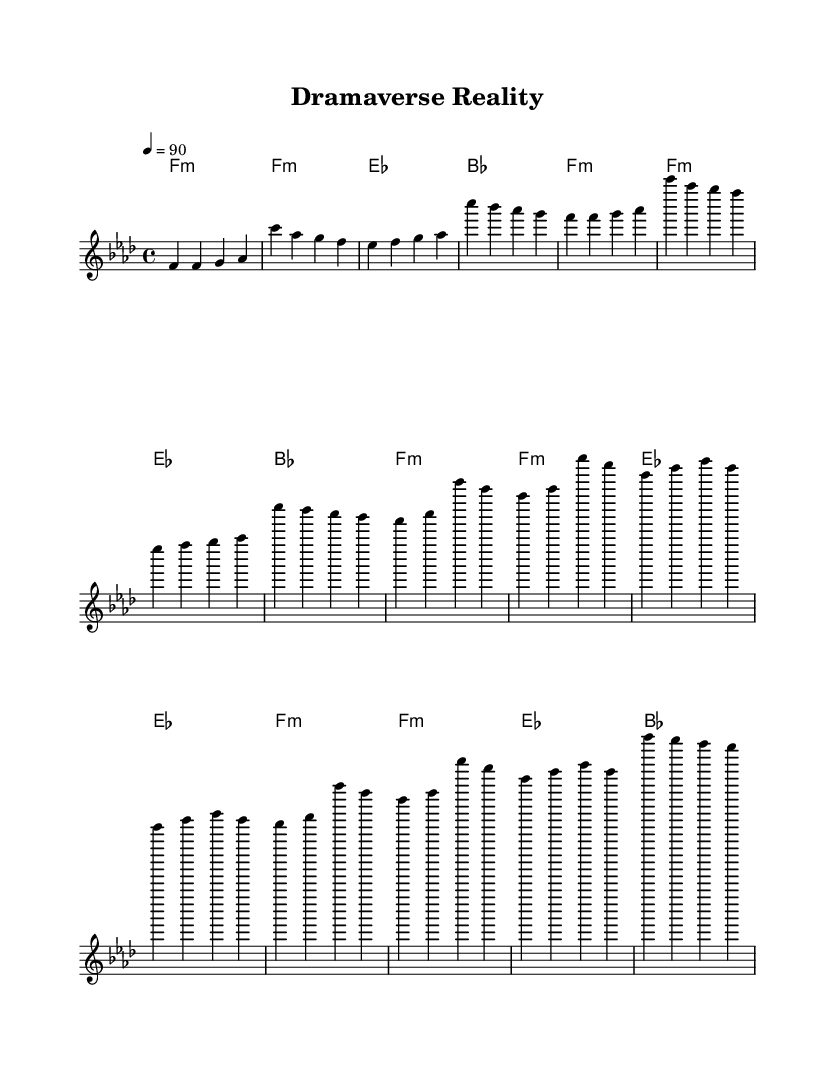What is the key signature of this music? The key signature is F minor, which consists of B flat, E flat, A flat, and D flat. In the sheet music, this is indicated at the beginning where the key signature is shown.
Answer: F minor What is the time signature of this music? The time signature is 4/4, which is indicated at the beginning of the sheet music. This means there are four beats in each measure, and the quarter note gets one beat.
Answer: 4/4 What is the tempo marking for this piece? The tempo marking is indicated as "4 = 90," which means there are 90 beats per minute. The number 4 refers to the quarter note, defining the speed of the piece.
Answer: 90 How many times does the melody repeat in the score? The melody section of the score has a pattern of repetition. In examining the repeated segments, we find that certain motifs occur throughout the piece. Counting these, the melody repeats twice.
Answer: Twice What chord appears most frequently in the harmonies? Reviewing the chords listed in the harmonies section, F minor appears as the first chord in several measures, making it the most frequent chord throughout the piece.
Answer: F minor What type of music does this sheet represent? The sheet represents socially conscious rap, which incorporates themes relevant to Pakistani culture and entertainment. This is reflected in the lyrical and structural elements of the piece indicated in the score.
Answer: Rap What is the overall mood suggested by the harmonies used? The use of minor chords in the harmonies, particularly F minor, suggests a serious or reflective mood, often found in socially conscious rap music that addresses profound themes. This is analyzed from the combination of chords listed in the score.
Answer: Serious 